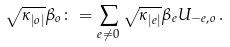Convert formula to latex. <formula><loc_0><loc_0><loc_500><loc_500>\sqrt { \kappa _ { | o | } } \beta _ { o } \colon = \sum _ { e \neq 0 } \sqrt { \kappa _ { | e | } } \beta _ { e } U _ { - e , o } \, .</formula> 